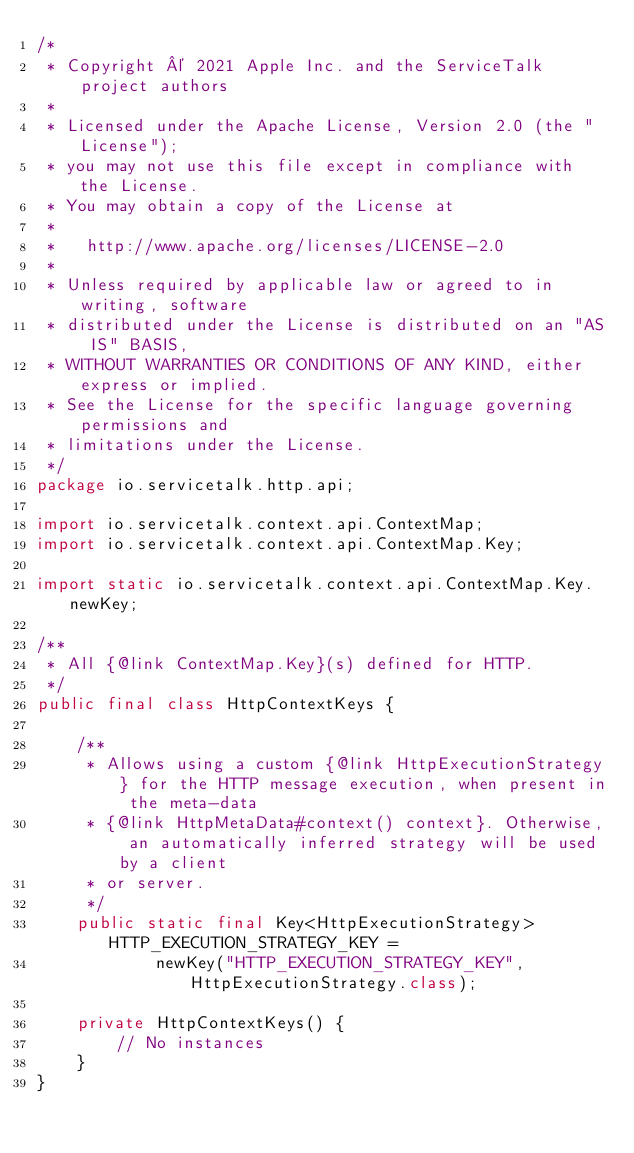<code> <loc_0><loc_0><loc_500><loc_500><_Java_>/*
 * Copyright © 2021 Apple Inc. and the ServiceTalk project authors
 *
 * Licensed under the Apache License, Version 2.0 (the "License");
 * you may not use this file except in compliance with the License.
 * You may obtain a copy of the License at
 *
 *   http://www.apache.org/licenses/LICENSE-2.0
 *
 * Unless required by applicable law or agreed to in writing, software
 * distributed under the License is distributed on an "AS IS" BASIS,
 * WITHOUT WARRANTIES OR CONDITIONS OF ANY KIND, either express or implied.
 * See the License for the specific language governing permissions and
 * limitations under the License.
 */
package io.servicetalk.http.api;

import io.servicetalk.context.api.ContextMap;
import io.servicetalk.context.api.ContextMap.Key;

import static io.servicetalk.context.api.ContextMap.Key.newKey;

/**
 * All {@link ContextMap.Key}(s) defined for HTTP.
 */
public final class HttpContextKeys {

    /**
     * Allows using a custom {@link HttpExecutionStrategy} for the HTTP message execution, when present in the meta-data
     * {@link HttpMetaData#context() context}. Otherwise, an automatically inferred strategy will be used by a client
     * or server.
     */
    public static final Key<HttpExecutionStrategy> HTTP_EXECUTION_STRATEGY_KEY =
            newKey("HTTP_EXECUTION_STRATEGY_KEY", HttpExecutionStrategy.class);

    private HttpContextKeys() {
        // No instances
    }
}
</code> 